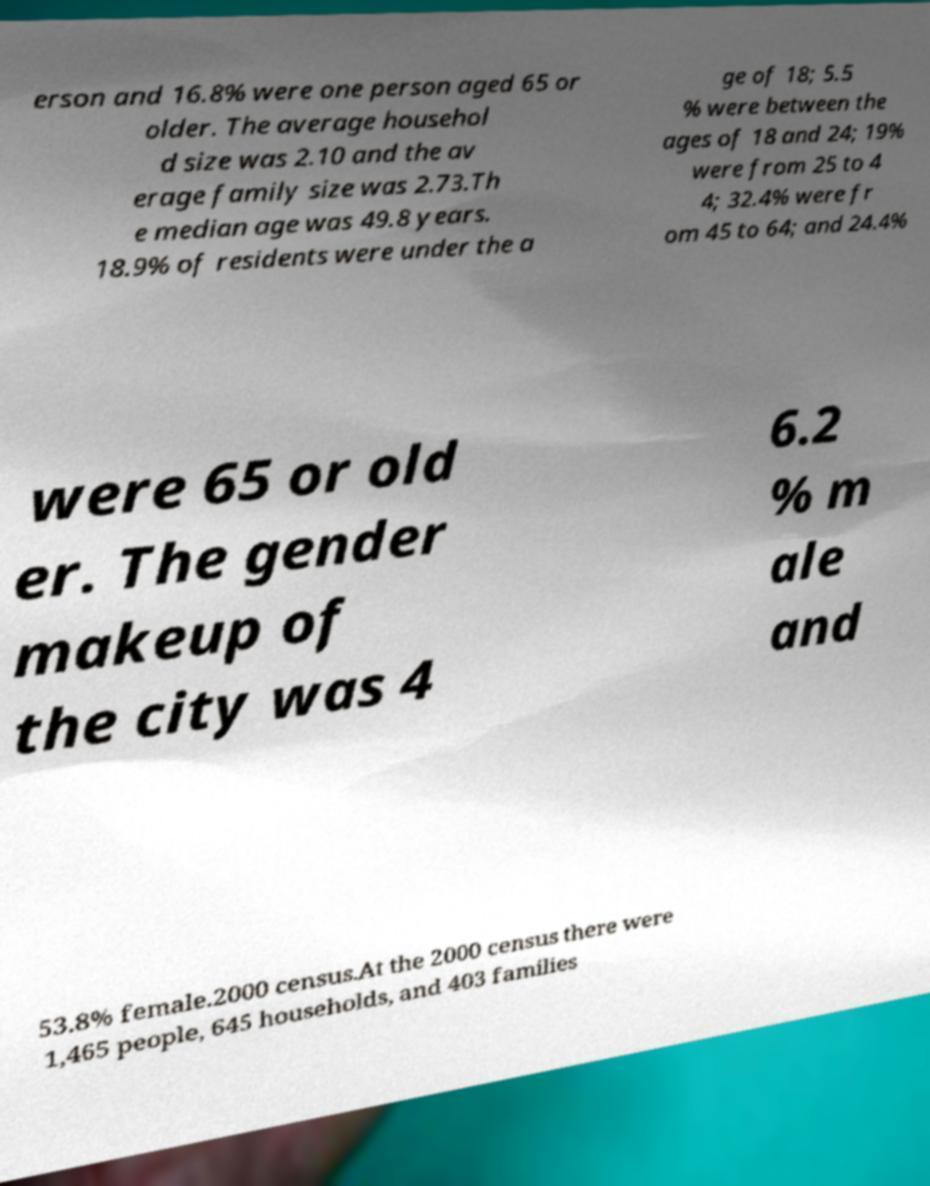For documentation purposes, I need the text within this image transcribed. Could you provide that? erson and 16.8% were one person aged 65 or older. The average househol d size was 2.10 and the av erage family size was 2.73.Th e median age was 49.8 years. 18.9% of residents were under the a ge of 18; 5.5 % were between the ages of 18 and 24; 19% were from 25 to 4 4; 32.4% were fr om 45 to 64; and 24.4% were 65 or old er. The gender makeup of the city was 4 6.2 % m ale and 53.8% female.2000 census.At the 2000 census there were 1,465 people, 645 households, and 403 families 